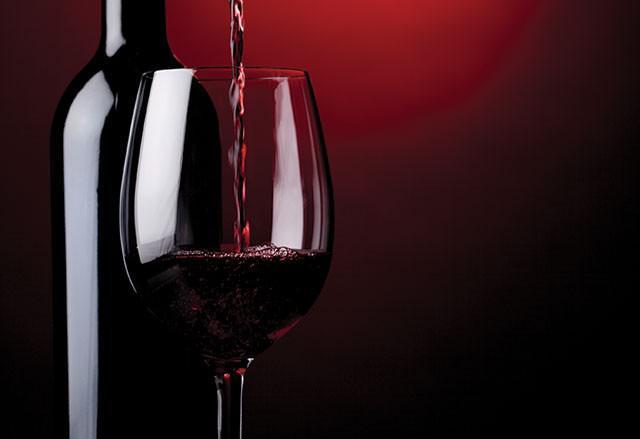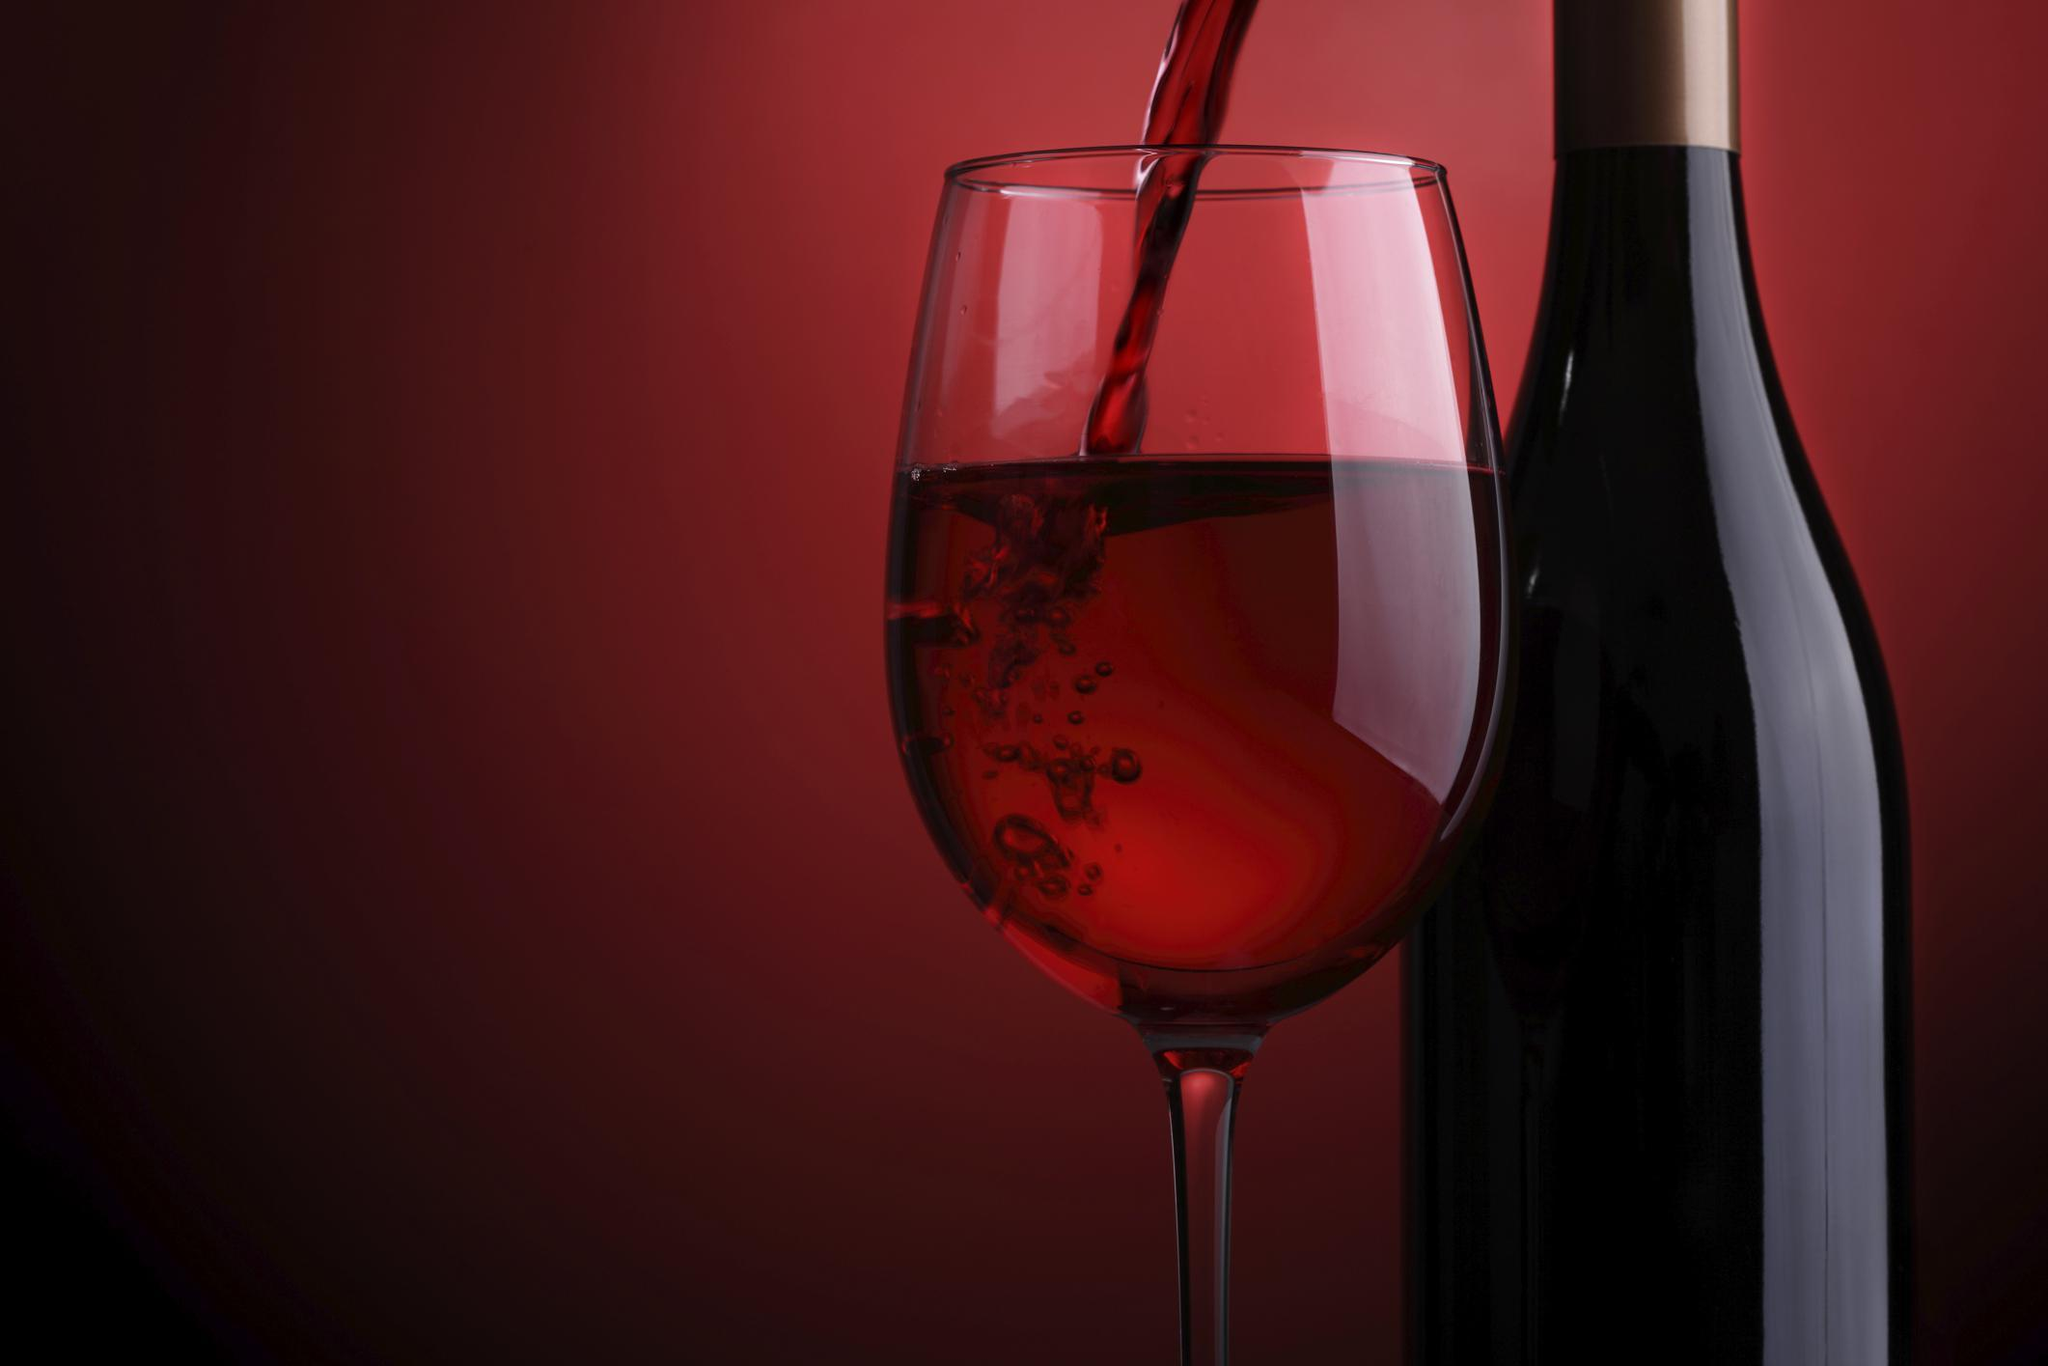The first image is the image on the left, the second image is the image on the right. Assess this claim about the two images: "The left image features exactly two wine glasses.". Correct or not? Answer yes or no. No. 